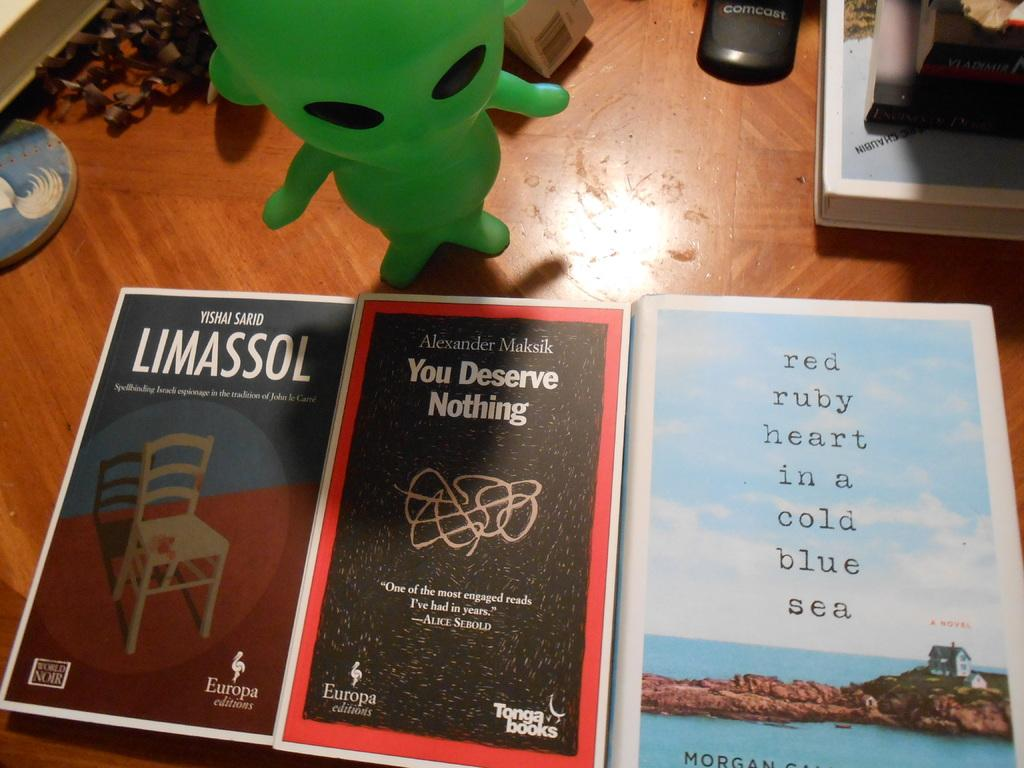<image>
Create a compact narrative representing the image presented. Three books including one called You Deserve Nothing are by a green alien figurine. 